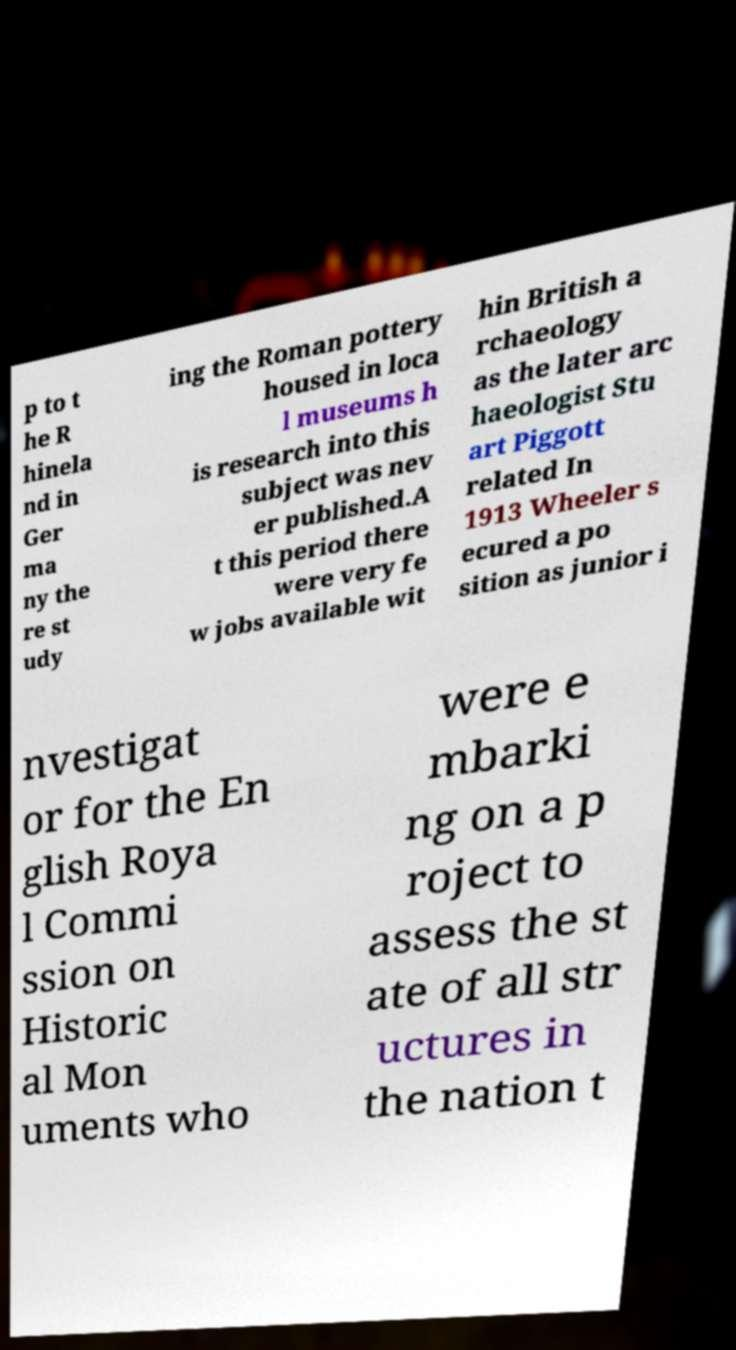I need the written content from this picture converted into text. Can you do that? p to t he R hinela nd in Ger ma ny the re st udy ing the Roman pottery housed in loca l museums h is research into this subject was nev er published.A t this period there were very fe w jobs available wit hin British a rchaeology as the later arc haeologist Stu art Piggott related In 1913 Wheeler s ecured a po sition as junior i nvestigat or for the En glish Roya l Commi ssion on Historic al Mon uments who were e mbarki ng on a p roject to assess the st ate of all str uctures in the nation t 